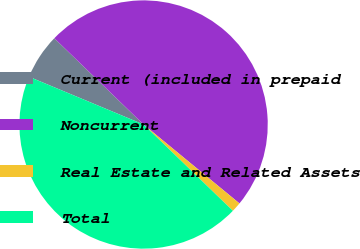<chart> <loc_0><loc_0><loc_500><loc_500><pie_chart><fcel>Current (included in prepaid<fcel>Noncurrent<fcel>Real Estate and Related Assets<fcel>Total<nl><fcel>5.94%<fcel>48.73%<fcel>1.27%<fcel>44.06%<nl></chart> 